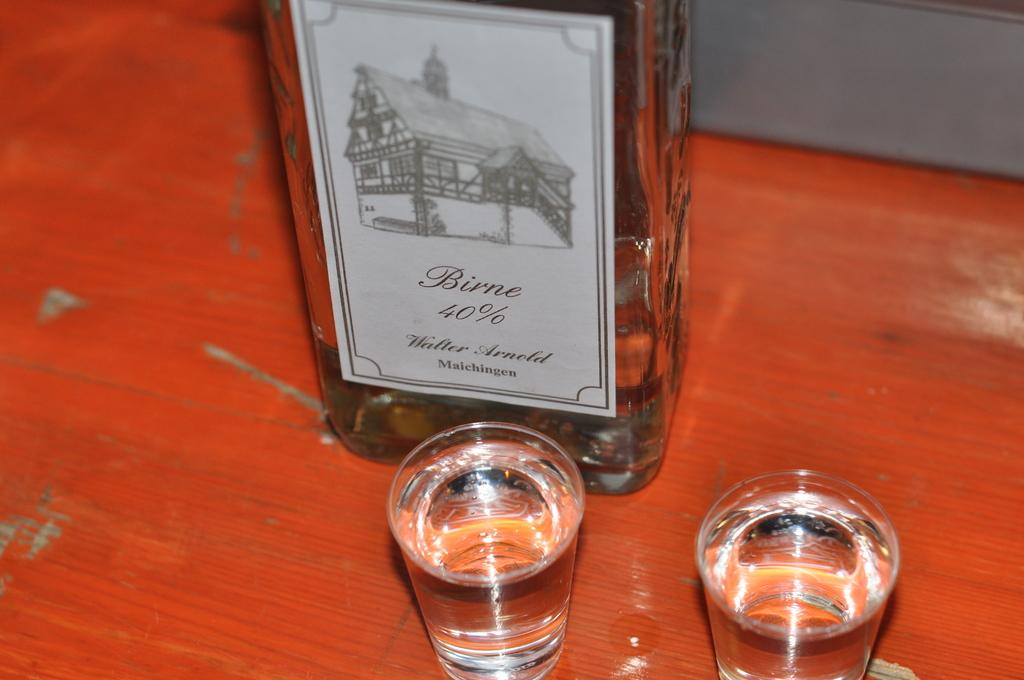<image>
Offer a succinct explanation of the picture presented. Two shot glasses are next to a Birne liquor bottle. 